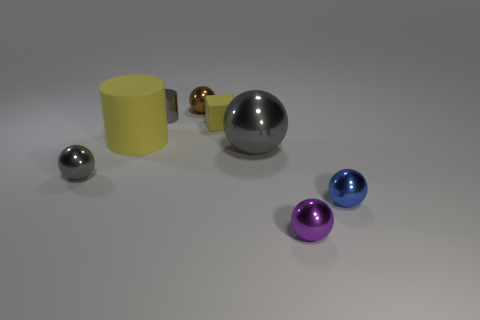Subtract all tiny brown spheres. How many spheres are left? 4 Subtract all purple spheres. How many spheres are left? 4 Add 2 large yellow rubber cylinders. How many objects exist? 10 Subtract 2 cylinders. How many cylinders are left? 0 Subtract all cylinders. How many objects are left? 6 Subtract all green cylinders. How many gray spheres are left? 2 Add 8 purple metal objects. How many purple metal objects are left? 9 Add 5 small matte cubes. How many small matte cubes exist? 6 Subtract 0 blue cylinders. How many objects are left? 8 Subtract all purple spheres. Subtract all purple blocks. How many spheres are left? 4 